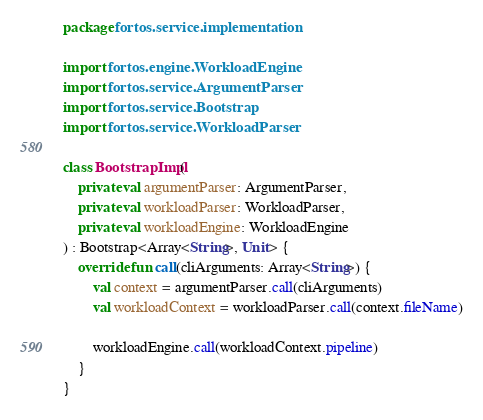Convert code to text. <code><loc_0><loc_0><loc_500><loc_500><_Kotlin_>package fortos.service.implementation

import fortos.engine.WorkloadEngine
import fortos.service.ArgumentParser
import fortos.service.Bootstrap
import fortos.service.WorkloadParser

class BootstrapImpl(
    private val argumentParser: ArgumentParser,
    private val workloadParser: WorkloadParser,
    private val workloadEngine: WorkloadEngine
) : Bootstrap<Array<String>, Unit> {
    override fun call(cliArguments: Array<String>) {
        val context = argumentParser.call(cliArguments)
        val workloadContext = workloadParser.call(context.fileName)

        workloadEngine.call(workloadContext.pipeline)
    }
}
</code> 